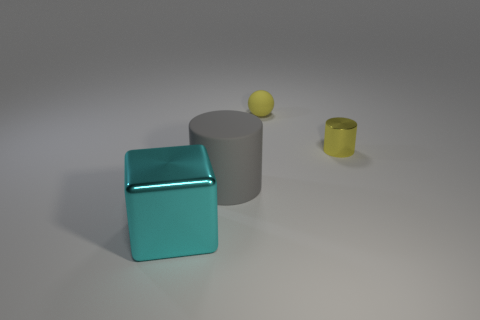Add 4 tiny purple metal things. How many objects exist? 8 Subtract all blocks. How many objects are left? 3 Add 1 tiny cyan shiny spheres. How many tiny cyan shiny spheres exist? 1 Subtract 0 red cylinders. How many objects are left? 4 Subtract all tiny purple rubber blocks. Subtract all big things. How many objects are left? 2 Add 2 yellow metallic cylinders. How many yellow metallic cylinders are left? 3 